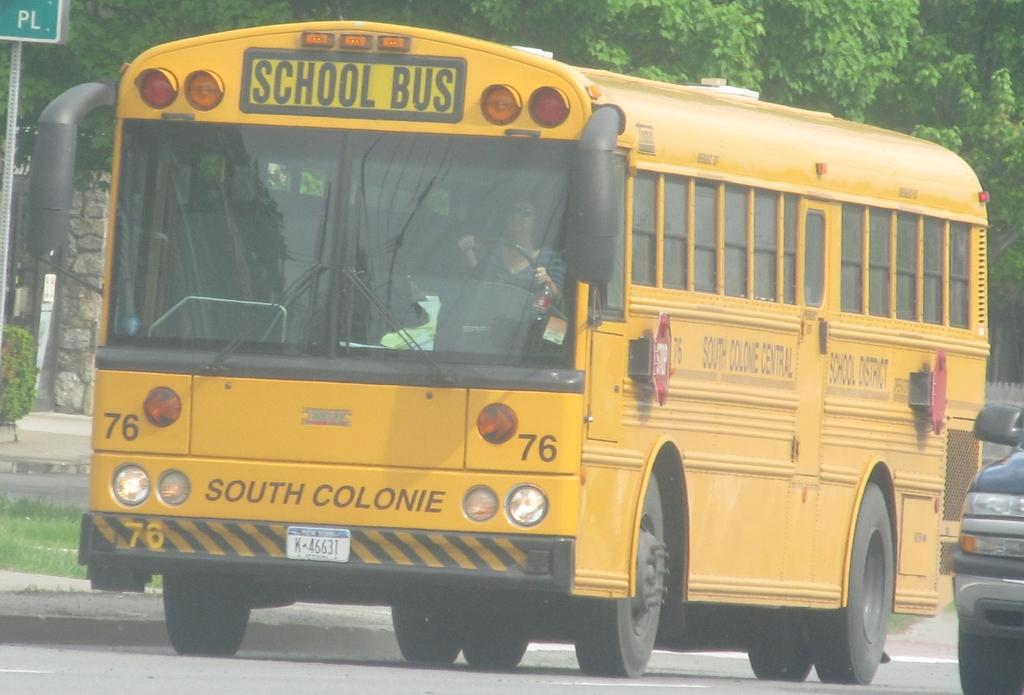<image>
Describe the image concisely. A flat nose yellow school bus from South Colonie school district. 